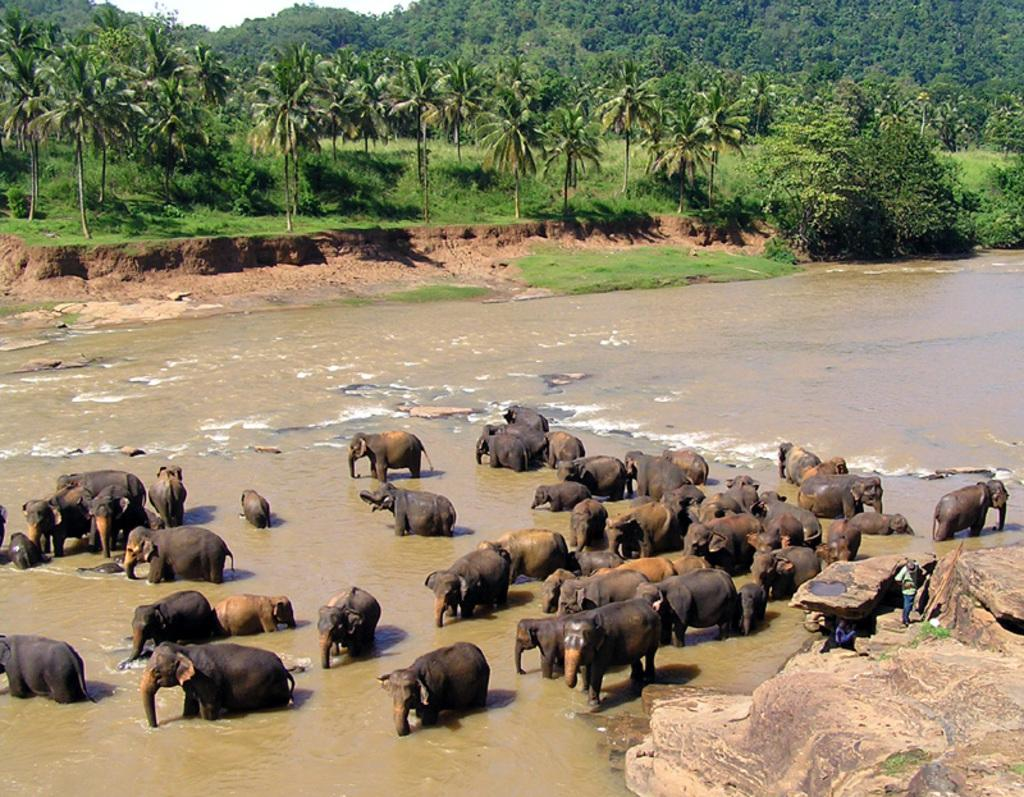What animals can be seen in the water in the image? There are many elephants standing in the water in the image. What object can be seen in the right bottom corner of the image? There is a rock in the right bottom corner of the image. What is happening on the rock? Two persons are on the rock. What can be seen in the background of the image? There are trees and plants in the background of the image. What sound does the judge make in the image? There is no judge present in the image, so it is not possible to determine what sound they might make. 